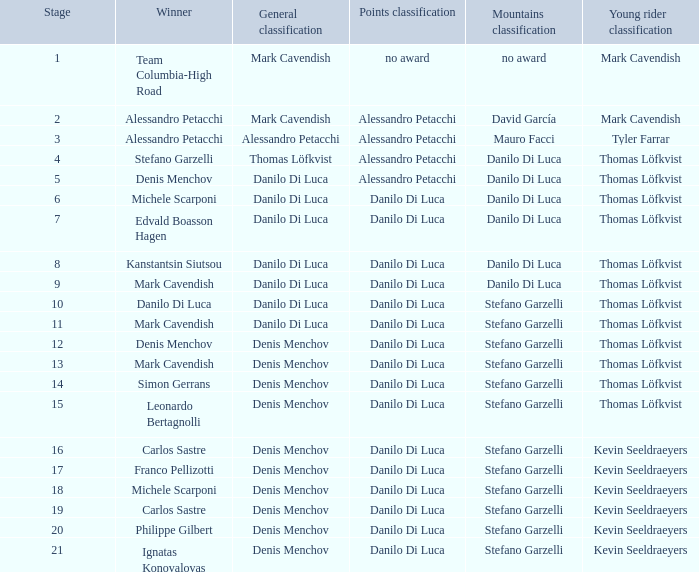I'm looking to parse the entire table for insights. Could you assist me with that? {'header': ['Stage', 'Winner', 'General classification', 'Points classification', 'Mountains classification', 'Young rider classification'], 'rows': [['1', 'Team Columbia-High Road', 'Mark Cavendish', 'no award', 'no award', 'Mark Cavendish'], ['2', 'Alessandro Petacchi', 'Mark Cavendish', 'Alessandro Petacchi', 'David García', 'Mark Cavendish'], ['3', 'Alessandro Petacchi', 'Alessandro Petacchi', 'Alessandro Petacchi', 'Mauro Facci', 'Tyler Farrar'], ['4', 'Stefano Garzelli', 'Thomas Löfkvist', 'Alessandro Petacchi', 'Danilo Di Luca', 'Thomas Löfkvist'], ['5', 'Denis Menchov', 'Danilo Di Luca', 'Alessandro Petacchi', 'Danilo Di Luca', 'Thomas Löfkvist'], ['6', 'Michele Scarponi', 'Danilo Di Luca', 'Danilo Di Luca', 'Danilo Di Luca', 'Thomas Löfkvist'], ['7', 'Edvald Boasson Hagen', 'Danilo Di Luca', 'Danilo Di Luca', 'Danilo Di Luca', 'Thomas Löfkvist'], ['8', 'Kanstantsin Siutsou', 'Danilo Di Luca', 'Danilo Di Luca', 'Danilo Di Luca', 'Thomas Löfkvist'], ['9', 'Mark Cavendish', 'Danilo Di Luca', 'Danilo Di Luca', 'Danilo Di Luca', 'Thomas Löfkvist'], ['10', 'Danilo Di Luca', 'Danilo Di Luca', 'Danilo Di Luca', 'Stefano Garzelli', 'Thomas Löfkvist'], ['11', 'Mark Cavendish', 'Danilo Di Luca', 'Danilo Di Luca', 'Stefano Garzelli', 'Thomas Löfkvist'], ['12', 'Denis Menchov', 'Denis Menchov', 'Danilo Di Luca', 'Stefano Garzelli', 'Thomas Löfkvist'], ['13', 'Mark Cavendish', 'Denis Menchov', 'Danilo Di Luca', 'Stefano Garzelli', 'Thomas Löfkvist'], ['14', 'Simon Gerrans', 'Denis Menchov', 'Danilo Di Luca', 'Stefano Garzelli', 'Thomas Löfkvist'], ['15', 'Leonardo Bertagnolli', 'Denis Menchov', 'Danilo Di Luca', 'Stefano Garzelli', 'Thomas Löfkvist'], ['16', 'Carlos Sastre', 'Denis Menchov', 'Danilo Di Luca', 'Stefano Garzelli', 'Kevin Seeldraeyers'], ['17', 'Franco Pellizotti', 'Denis Menchov', 'Danilo Di Luca', 'Stefano Garzelli', 'Kevin Seeldraeyers'], ['18', 'Michele Scarponi', 'Denis Menchov', 'Danilo Di Luca', 'Stefano Garzelli', 'Kevin Seeldraeyers'], ['19', 'Carlos Sastre', 'Denis Menchov', 'Danilo Di Luca', 'Stefano Garzelli', 'Kevin Seeldraeyers'], ['20', 'Philippe Gilbert', 'Denis Menchov', 'Danilo Di Luca', 'Stefano Garzelli', 'Kevin Seeldraeyers'], ['21', 'Ignatas Konovalovas', 'Denis Menchov', 'Danilo Di Luca', 'Stefano Garzelli', 'Kevin Seeldraeyers']]} When philippe gilbert is the winner who is the points classification? Danilo Di Luca. 